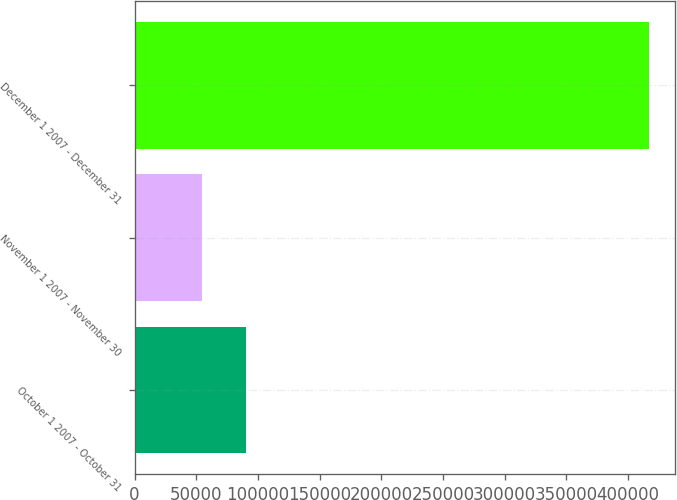Convert chart. <chart><loc_0><loc_0><loc_500><loc_500><bar_chart><fcel>October 1 2007 - October 31<fcel>November 1 2007 - November 30<fcel>December 1 2007 - December 31<nl><fcel>90587.9<fcel>54296<fcel>417215<nl></chart> 